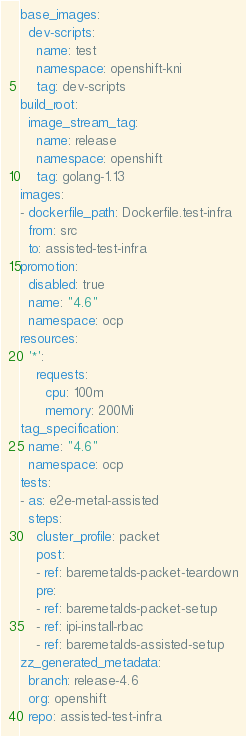<code> <loc_0><loc_0><loc_500><loc_500><_YAML_>base_images:
  dev-scripts:
    name: test
    namespace: openshift-kni
    tag: dev-scripts
build_root:
  image_stream_tag:
    name: release
    namespace: openshift
    tag: golang-1.13
images:
- dockerfile_path: Dockerfile.test-infra
  from: src
  to: assisted-test-infra
promotion:
  disabled: true
  name: "4.6"
  namespace: ocp
resources:
  '*':
    requests:
      cpu: 100m
      memory: 200Mi
tag_specification:
  name: "4.6"
  namespace: ocp
tests:
- as: e2e-metal-assisted
  steps:
    cluster_profile: packet
    post:
    - ref: baremetalds-packet-teardown
    pre:
    - ref: baremetalds-packet-setup
    - ref: ipi-install-rbac
    - ref: baremetalds-assisted-setup
zz_generated_metadata:
  branch: release-4.6
  org: openshift
  repo: assisted-test-infra
</code> 